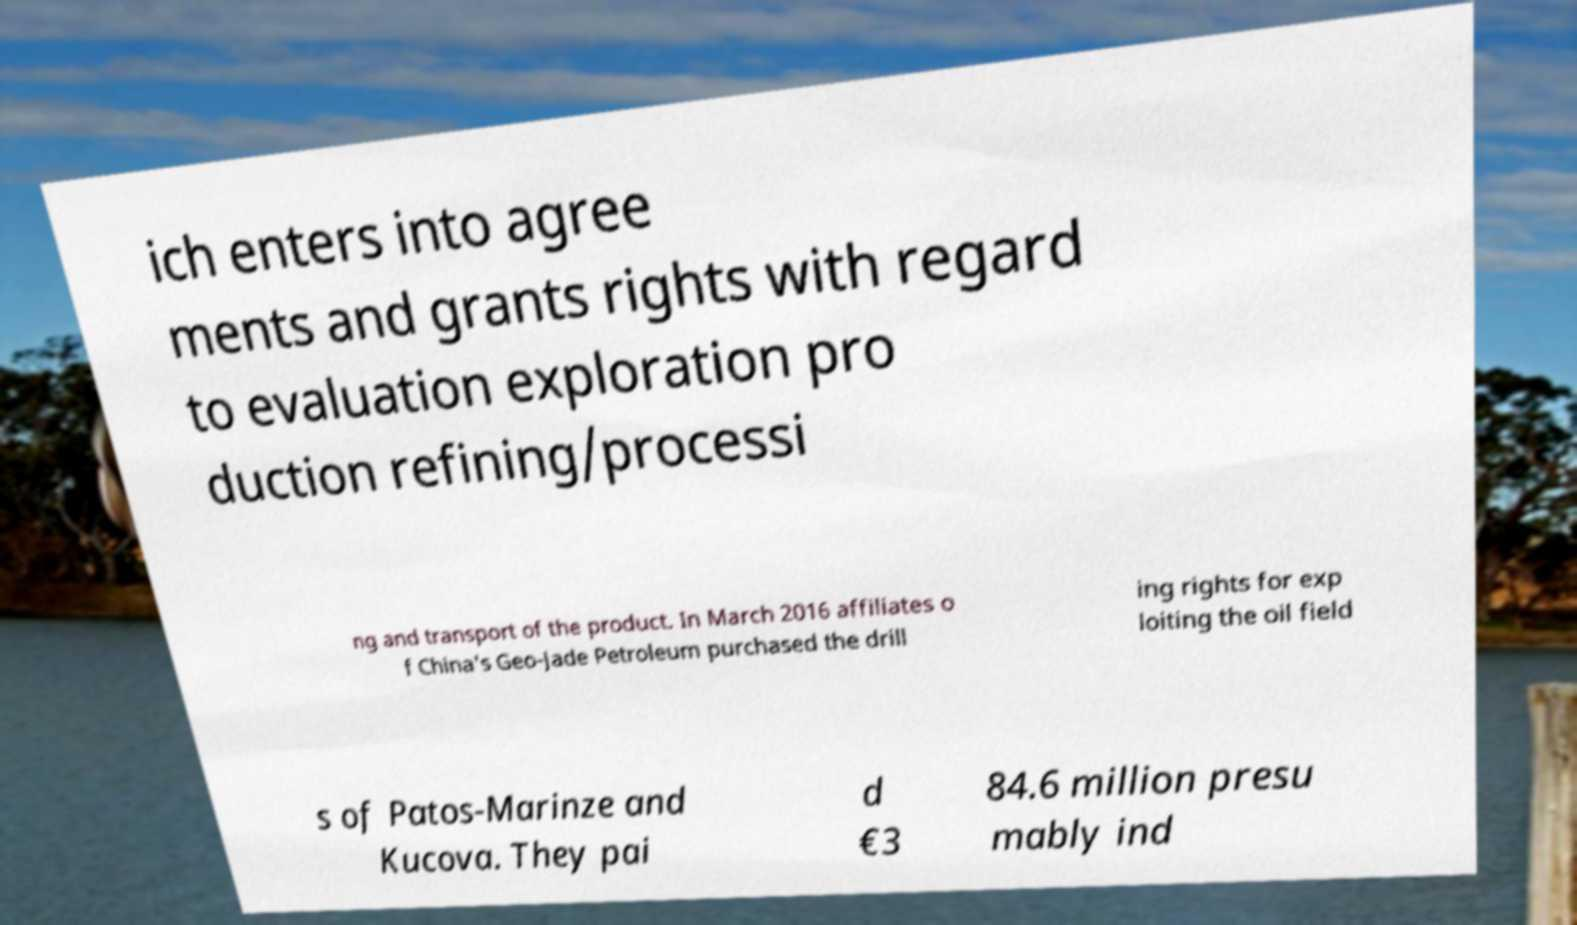Can you read and provide the text displayed in the image?This photo seems to have some interesting text. Can you extract and type it out for me? ich enters into agree ments and grants rights with regard to evaluation exploration pro duction refining/processi ng and transport of the product. In March 2016 affiliates o f China's Geo-Jade Petroleum purchased the drill ing rights for exp loiting the oil field s of Patos-Marinze and Kucova. They pai d €3 84.6 million presu mably ind 